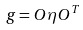Convert formula to latex. <formula><loc_0><loc_0><loc_500><loc_500>g = O \eta O ^ { T }</formula> 